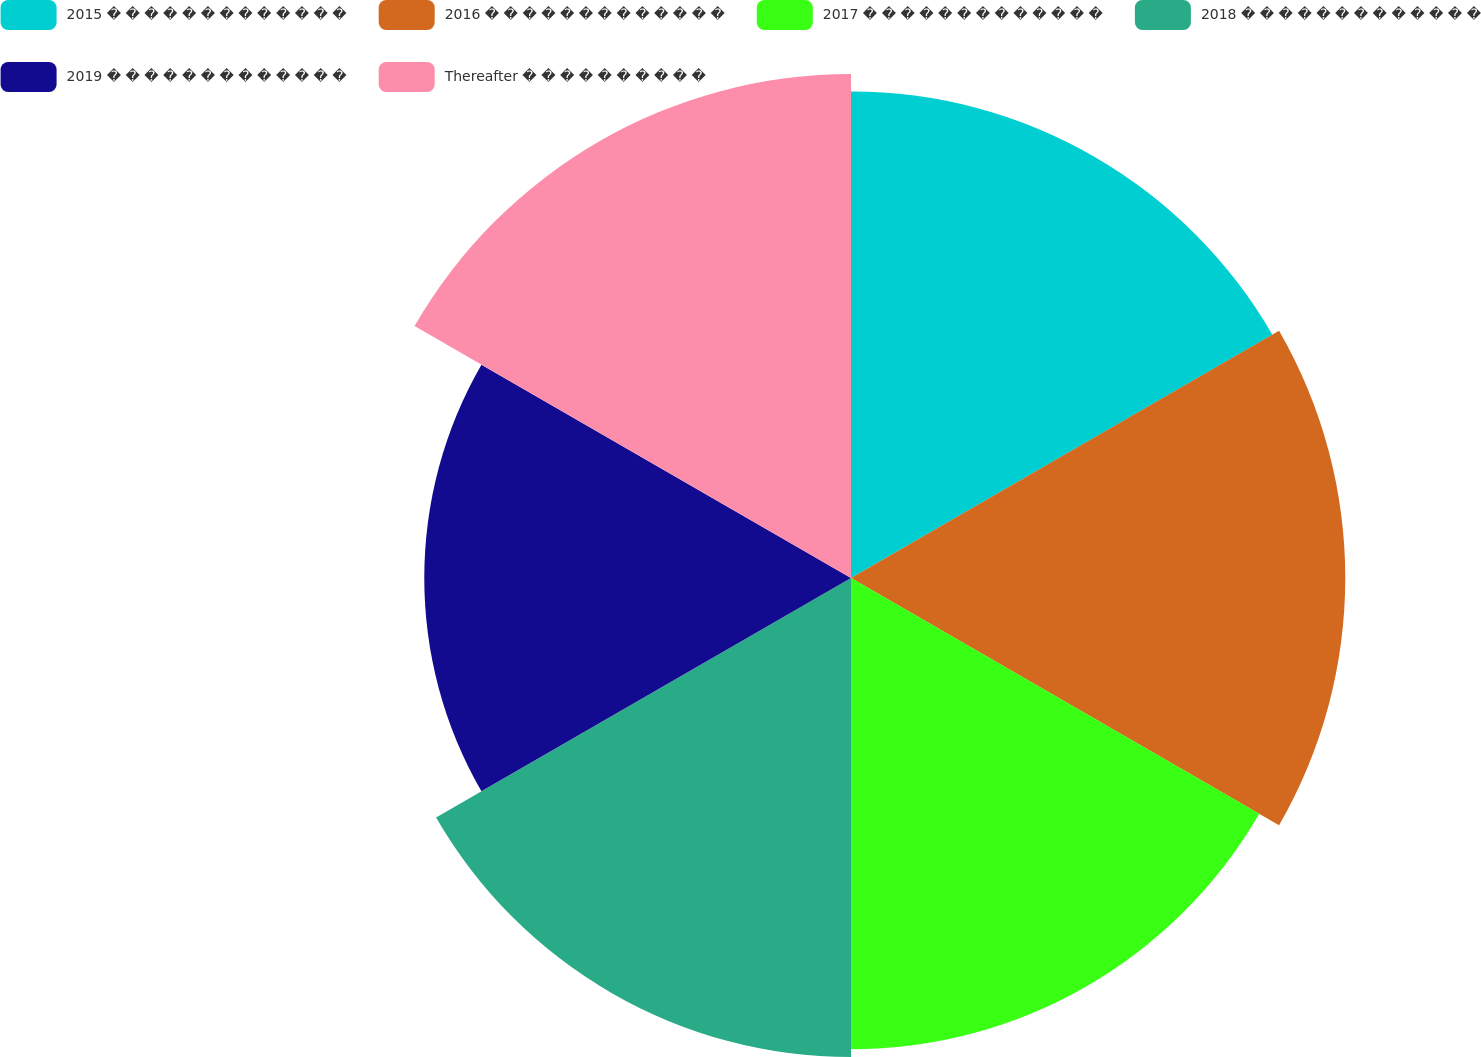Convert chart to OTSL. <chart><loc_0><loc_0><loc_500><loc_500><pie_chart><fcel>2015 � � � � � � � � � � � � �<fcel>2016 � � � � � � � � � � � � �<fcel>2017 � � � � � � � � � � � � �<fcel>2018 � � � � � � � � � � � � �<fcel>2019 � � � � � � � � � � � � �<fcel>Thereafter � � � � � � � � � �<nl><fcel>17.0%<fcel>17.27%<fcel>16.47%<fcel>16.74%<fcel>14.91%<fcel>17.61%<nl></chart> 